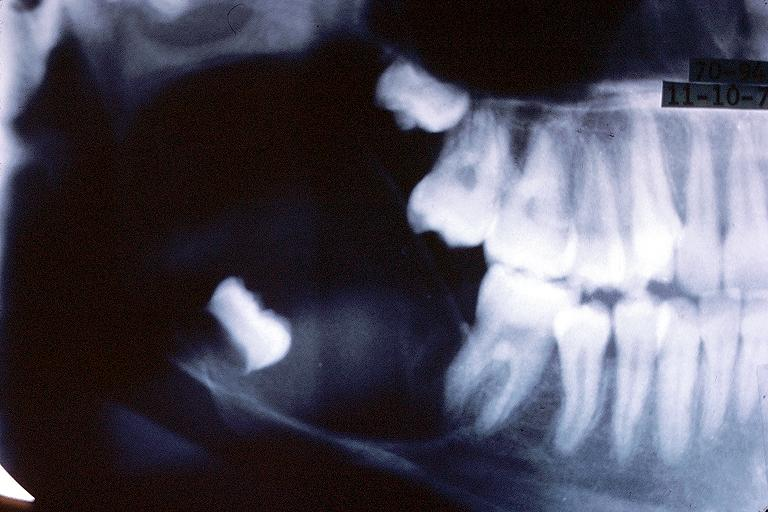s oral present?
Answer the question using a single word or phrase. Yes 